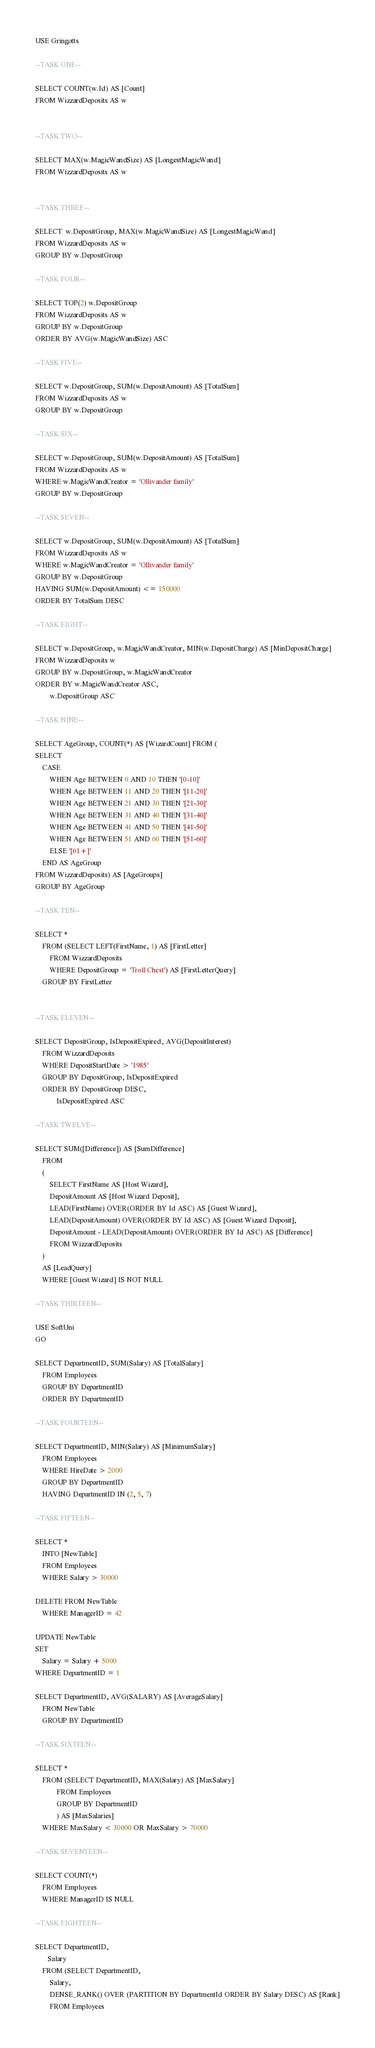<code> <loc_0><loc_0><loc_500><loc_500><_SQL_>USE Gringotts

--TASK ONE--

SELECT COUNT(w.Id) AS [Count]
FROM WizzardDeposits AS w


--TASK TWO--

SELECT MAX(w.MagicWandSize) AS [LongestMagicWand]
FROM WizzardDeposits AS w


--TASK THREE--

SELECT  w.DepositGroup, MAX(w.MagicWandSize) AS [LongestMagicWand]
FROM WizzardDeposits AS w
GROUP BY w.DepositGroup

--TASK FOUR--

SELECT TOP(2) w.DepositGroup
FROM WizzardDeposits AS w
GROUP BY w.DepositGroup
ORDER BY AVG(w.MagicWandSize) ASC

--TASK FIVE--

SELECT w.DepositGroup, SUM(w.DepositAmount) AS [TotalSum]
FROM WizzardDeposits AS w
GROUP BY w.DepositGroup

--TASK SIX--

SELECT w.DepositGroup, SUM(w.DepositAmount) AS [TotalSum]
FROM WizzardDeposits AS w
WHERE w.MagicWandCreator = 'Ollivander family'
GROUP BY w.DepositGroup

--TASK SEVEN--

SELECT w.DepositGroup, SUM(w.DepositAmount) AS [TotalSum]
FROM WizzardDeposits AS w
WHERE w.MagicWandCreator = 'Ollivander family'
GROUP BY w.DepositGroup
HAVING SUM(w.DepositAmount) <= 150000
ORDER BY TotalSum DESC

--TASK EIGHT--

SELECT w.DepositGroup, w.MagicWandCreator, MIN(w.DepositCharge) AS [MinDepositCharge]  
FROM WizzardDeposits w
GROUP BY w.DepositGroup, w.MagicWandCreator
ORDER BY w.MagicWandCreator ASC,
		w.DepositGroup ASC

--TASK NINE--

SELECT AgeGroup, COUNT(*) AS [WizardCount] FROM (
SELECT 
	CASE
		WHEN Age BETWEEN 0 AND 10 THEN '[0-10]'
		WHEN Age BETWEEN 11 AND 20 THEN '[11-20]'
		WHEN Age BETWEEN 21 AND 30 THEN '[21-30]'
		WHEN Age BETWEEN 31 AND 40 THEN '[31-40]'
		WHEN Age BETWEEN 41 AND 50 THEN '[41-50]'
		WHEN Age BETWEEN 51 AND 60 THEN '[51-60]'
		ELSE '[61+]'
	END AS AgeGroup
FROM WizzardDeposits) AS [AgeGroups]
GROUP BY AgeGroup

--TASK TEN--

SELECT *
	FROM (SELECT LEFT(FirstName, 1) AS [FirstLetter]
		FROM WizzardDeposits
		WHERE DepositGroup = 'Troll Chest') AS [FirstLetterQuery]
	GROUP BY FirstLetter
	

--TASK ELEVEN--

SELECT DepositGroup, IsDepositExpired, AVG(DepositInterest)
	FROM WizzardDeposits
	WHERE DepositStartDate > '1985'
	GROUP BY DepositGroup, IsDepositExpired
	ORDER BY DepositGroup DESC,
			IsDepositExpired ASC

--TASK TWELVE--

SELECT SUM([Difference]) AS [SumDifference]
	FROM 
	(
		SELECT FirstName AS [Host Wizard],
		DepositAmount AS [Host Wizard Deposit],
		LEAD(FirstName) OVER(ORDER BY Id ASC) AS [Guest Wizard],
		LEAD(DepositAmount) OVER(ORDER BY Id ASC) AS [Guest Wizard Deposit],
		DepositAmount - LEAD(DepositAmount) OVER(ORDER BY Id ASC) AS [Difference]
		FROM WizzardDeposits
	)
	AS [LeadQuery]
	WHERE [Guest Wizard] IS NOT NULL

--TASK THIRTEEN--

USE SoftUni
GO

SELECT DepartmentID, SUM(Salary) AS [TotalSalary]
	FROM Employees
	GROUP BY DepartmentID
	ORDER BY DepartmentID

--TASK FOURTEEN--

SELECT DepartmentID, MIN(Salary) AS [MinimumSalary]
	FROM Employees
	WHERE HireDate > 2000
	GROUP BY DepartmentID
	HAVING DepartmentID IN (2, 5, 7)

--TASK FIFTEEN--

SELECT *
	INTO [NewTable]
	FROM Employees
	WHERE Salary > 30000

DELETE FROM NewTable
	WHERE ManagerID = 42

UPDATE NewTable
SET
	Salary = Salary + 5000
WHERE DepartmentID = 1

SELECT DepartmentID, AVG(SALARY) AS [AverageSalary]
	FROM NewTable
	GROUP BY DepartmentID

--TASK SIXTEEN--

SELECT * 
	FROM (SELECT DepartmentID, MAX(Salary) AS [MaxSalary]
			FROM Employees
			GROUP BY DepartmentID
			) AS [MaxSalaries]
	WHERE MaxSalary < 30000 OR MaxSalary > 70000

--TASK SEVENTEEN--

SELECT COUNT(*)
	FROM Employees
	WHERE ManagerID IS NULL

--TASK EIGHTEEN--

SELECT DepartmentID,
	   Salary	   
	FROM (SELECT DepartmentID, 
		Salary,
		DENSE_RANK() OVER (PARTITION BY DepartmentId ORDER BY Salary DESC) AS [Rank]
		FROM Employees</code> 